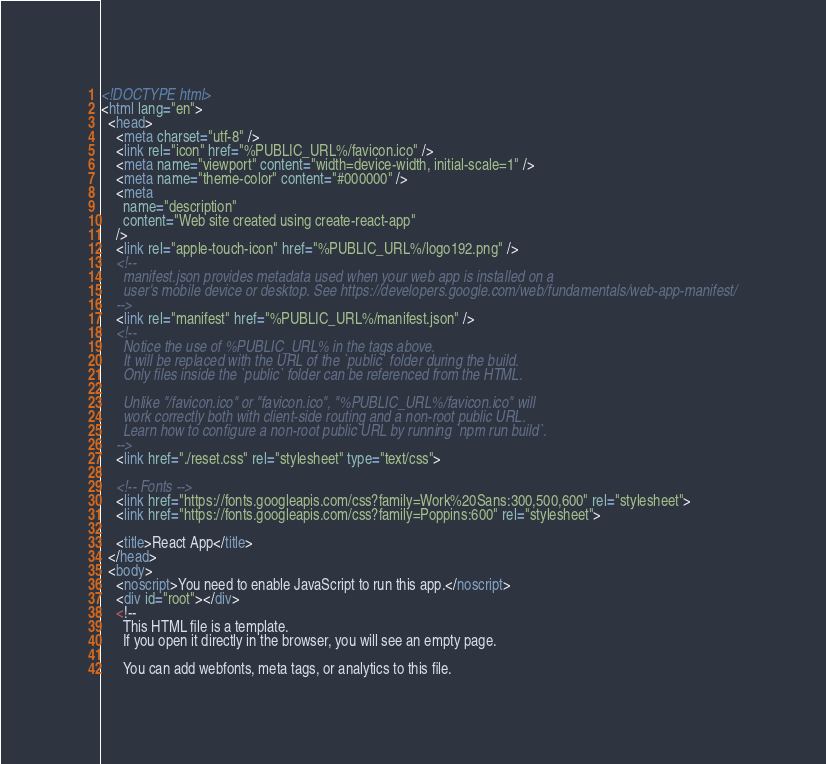Convert code to text. <code><loc_0><loc_0><loc_500><loc_500><_HTML_><!DOCTYPE html>
<html lang="en">
  <head>
    <meta charset="utf-8" />
    <link rel="icon" href="%PUBLIC_URL%/favicon.ico" />
    <meta name="viewport" content="width=device-width, initial-scale=1" />
    <meta name="theme-color" content="#000000" />
    <meta
      name="description"
      content="Web site created using create-react-app"
    />
    <link rel="apple-touch-icon" href="%PUBLIC_URL%/logo192.png" />
    <!--
      manifest.json provides metadata used when your web app is installed on a
      user's mobile device or desktop. See https://developers.google.com/web/fundamentals/web-app-manifest/
    -->
    <link rel="manifest" href="%PUBLIC_URL%/manifest.json" />
    <!--
      Notice the use of %PUBLIC_URL% in the tags above.
      It will be replaced with the URL of the `public` folder during the build.
      Only files inside the `public` folder can be referenced from the HTML.

      Unlike "/favicon.ico" or "favicon.ico", "%PUBLIC_URL%/favicon.ico" will
      work correctly both with client-side routing and a non-root public URL.
      Learn how to configure a non-root public URL by running `npm run build`.
    -->
    <link href="./reset.css" rel="stylesheet" type="text/css">

    <!-- Fonts -->
    <link href="https://fonts.googleapis.com/css?family=Work%20Sans:300,500,600" rel="stylesheet">
    <link href="https://fonts.googleapis.com/css?family=Poppins:600" rel="stylesheet">

    <title>React App</title>
  </head>
  <body>
    <noscript>You need to enable JavaScript to run this app.</noscript>
    <div id="root"></div>
    <!--
      This HTML file is a template.
      If you open it directly in the browser, you will see an empty page.

      You can add webfonts, meta tags, or analytics to this file.</code> 